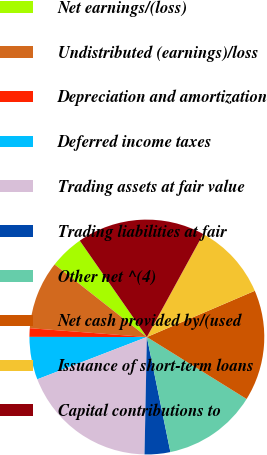Convert chart. <chart><loc_0><loc_0><loc_500><loc_500><pie_chart><fcel>Net earnings/(loss)<fcel>Undistributed (earnings)/loss<fcel>Depreciation and amortization<fcel>Deferred income taxes<fcel>Trading assets at fair value<fcel>Trading liabilities at fair<fcel>Other net ^(4)<fcel>Net cash provided by/(used<fcel>Issuance of short-term loans<fcel>Capital contributions to<nl><fcel>4.71%<fcel>9.41%<fcel>1.18%<fcel>5.88%<fcel>18.82%<fcel>3.53%<fcel>12.94%<fcel>15.29%<fcel>10.59%<fcel>17.65%<nl></chart> 